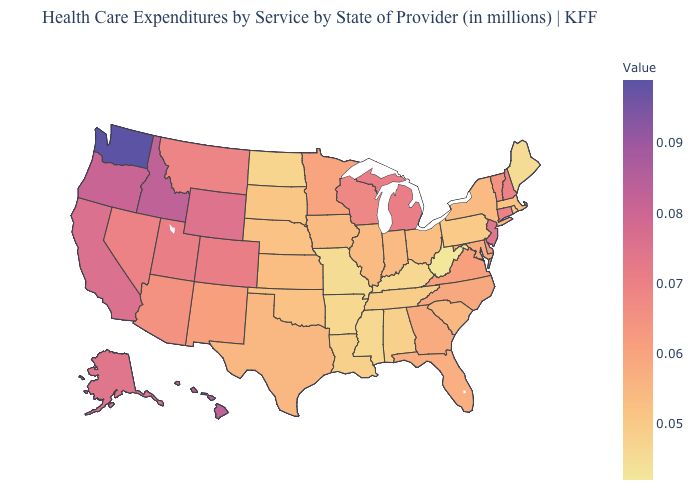Among the states that border Vermont , which have the highest value?
Give a very brief answer. New Hampshire. Among the states that border Florida , does Georgia have the highest value?
Concise answer only. Yes. Among the states that border Mississippi , does Tennessee have the highest value?
Quick response, please. Yes. Does the map have missing data?
Be succinct. No. Does Nevada have a higher value than Louisiana?
Keep it brief. Yes. Among the states that border New Hampshire , does Vermont have the highest value?
Keep it brief. Yes. 